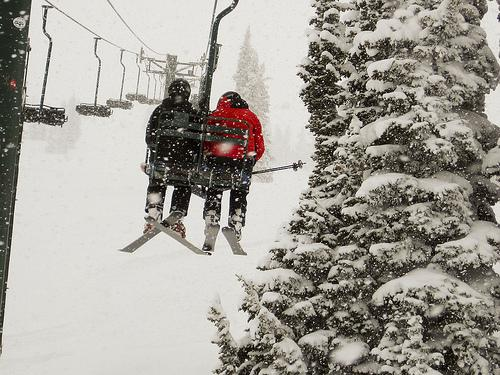Question: who has their skies crosses?
Choices:
A. The girl.
B. The two men.
C. The man on the right.
D. The person in black.
Answer with the letter. Answer: D Question: what are the people riding on?
Choices:
A. Horses.
B. ATVs.
C. A train.
D. Ski lift.
Answer with the letter. Answer: D Question: how many trees do you see?
Choices:
A. Three.
B. Two.
C. Four.
D. Five.
Answer with the letter. Answer: B Question: what color jackets are the people wearing?
Choices:
A. Black and white.
B. Black and red.
C. Red and white.
D. Blue and White.
Answer with the letter. Answer: B Question: what season is this?
Choices:
A. Winter.
B. Summer.
C. Spring.
D. Fall.
Answer with the letter. Answer: A Question: when does it snow?
Choices:
A. Winter.
B. When it's cold.
C. In January.
D. With low temperatures and precipitation.
Answer with the letter. Answer: A Question: what is the person in red holding?
Choices:
A. Tennis racquet.
B. Baseball bat.
C. Shopping bag.
D. Ski poles.
Answer with the letter. Answer: D 